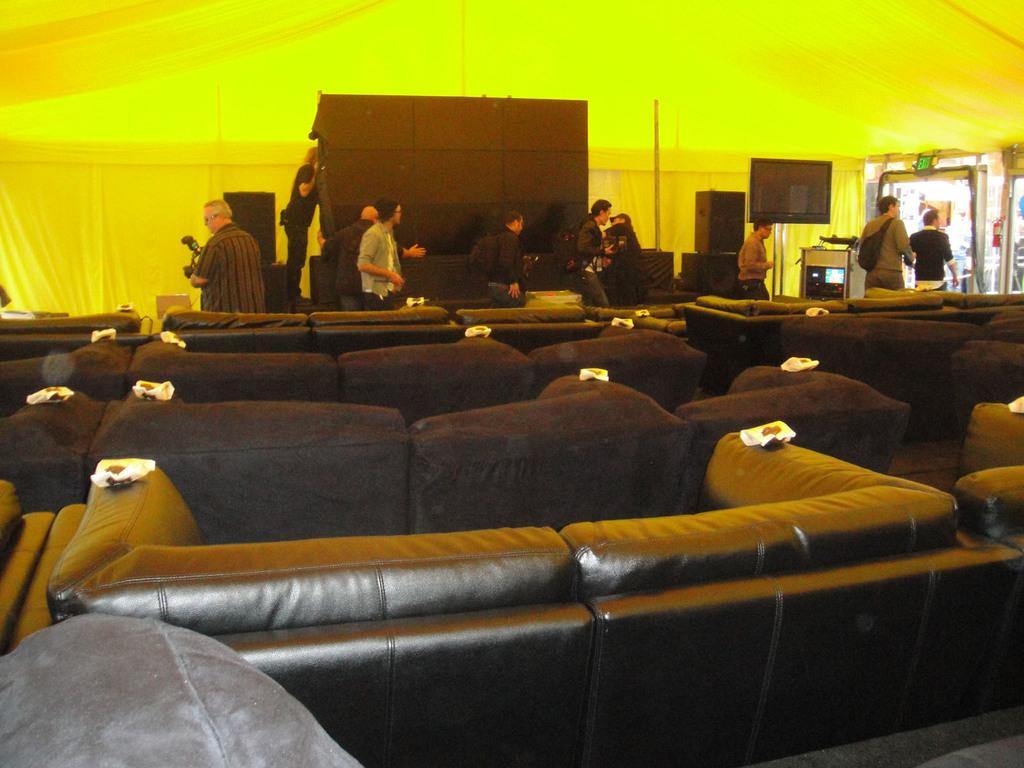What type of furniture is visible in the front of the image? There are many sofas in the front of the image. What is located in the back of the image? There is a black screen in the back of the image. What is placed on either side of the black screen? There are speakers on either side of the black screen. What are the people in the image doing? Many people are walking in front of the black screen. What is covering the black screen in the image? There is a tent above the black screen. Are there any office supplies visible on the sofas in the image? There is no mention of office supplies in the image; it features sofas, a black screen, speakers, and people walking. Can you hear any bells ringing in the image? There is no mention of bells or any sounds in the image. 